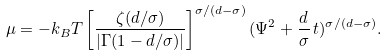Convert formula to latex. <formula><loc_0><loc_0><loc_500><loc_500>\mu = - k _ { B } T \left [ \frac { \zeta ( d / \sigma ) } { | \Gamma ( 1 - d / \sigma ) | } \right ] ^ { \sigma / ( d - \sigma ) } ( \Psi ^ { 2 } + \frac { d } { \sigma } \, t ) ^ { \sigma / ( d - \sigma ) } .</formula> 